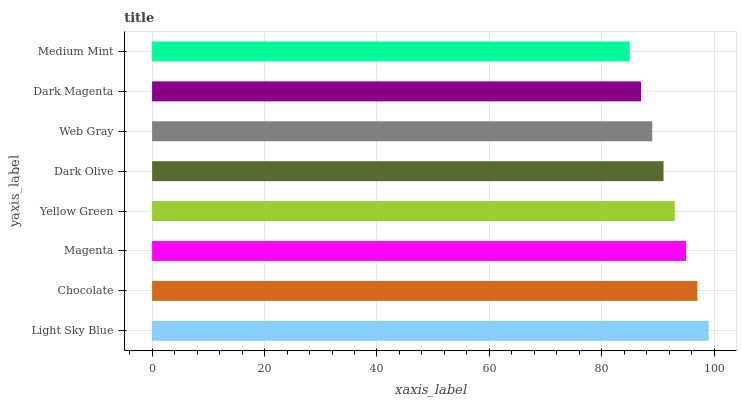Is Medium Mint the minimum?
Answer yes or no. Yes. Is Light Sky Blue the maximum?
Answer yes or no. Yes. Is Chocolate the minimum?
Answer yes or no. No. Is Chocolate the maximum?
Answer yes or no. No. Is Light Sky Blue greater than Chocolate?
Answer yes or no. Yes. Is Chocolate less than Light Sky Blue?
Answer yes or no. Yes. Is Chocolate greater than Light Sky Blue?
Answer yes or no. No. Is Light Sky Blue less than Chocolate?
Answer yes or no. No. Is Yellow Green the high median?
Answer yes or no. Yes. Is Dark Olive the low median?
Answer yes or no. Yes. Is Dark Magenta the high median?
Answer yes or no. No. Is Magenta the low median?
Answer yes or no. No. 